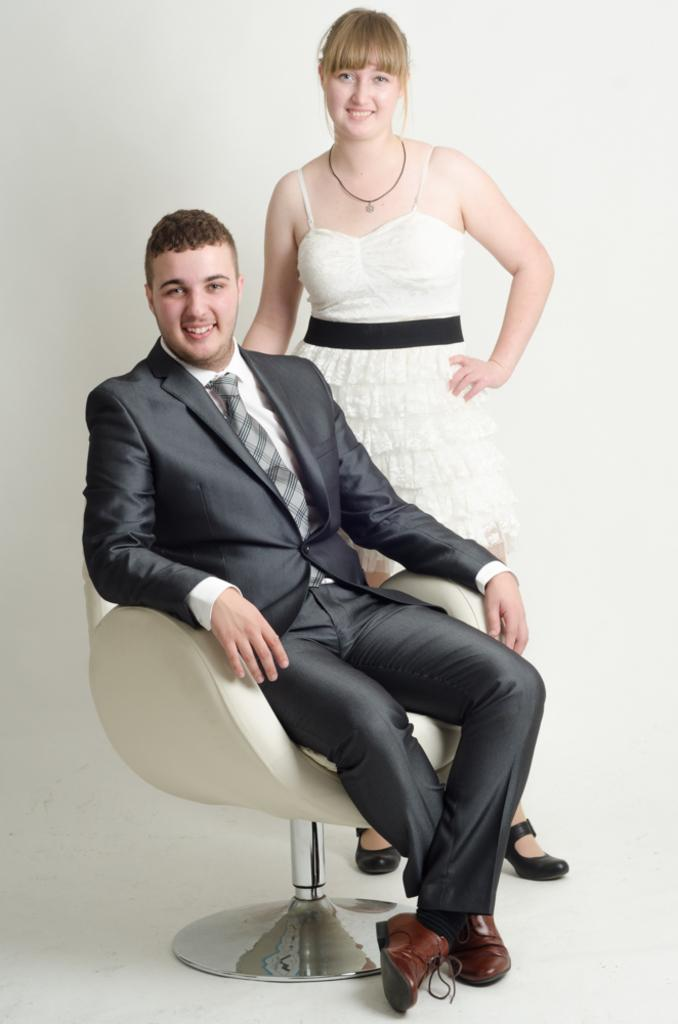What is happening between the two people in the image? The couple is kissing in the image. Can you describe the positions of the two people in the image? The woman is standing, while the man is sitting in a chair. What type of ray can be seen flying in the alley behind the couple in the image? There is no ray or alley present in the image; it features a couple kissing. 